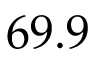Convert formula to latex. <formula><loc_0><loc_0><loc_500><loc_500>6 9 . 9</formula> 